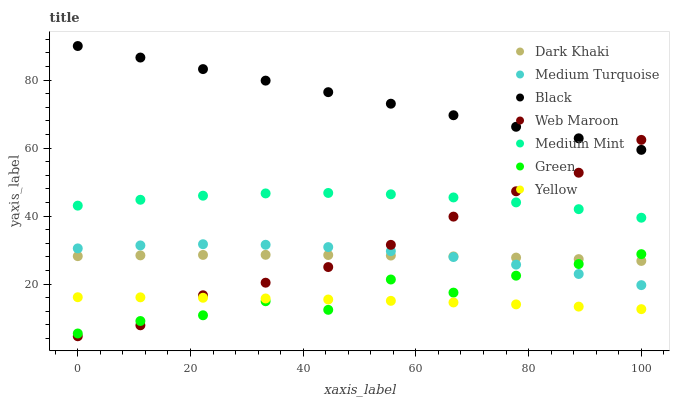Does Yellow have the minimum area under the curve?
Answer yes or no. Yes. Does Black have the maximum area under the curve?
Answer yes or no. Yes. Does Web Maroon have the minimum area under the curve?
Answer yes or no. No. Does Web Maroon have the maximum area under the curve?
Answer yes or no. No. Is Black the smoothest?
Answer yes or no. Yes. Is Green the roughest?
Answer yes or no. Yes. Is Web Maroon the smoothest?
Answer yes or no. No. Is Web Maroon the roughest?
Answer yes or no. No. Does Web Maroon have the lowest value?
Answer yes or no. Yes. Does Yellow have the lowest value?
Answer yes or no. No. Does Black have the highest value?
Answer yes or no. Yes. Does Web Maroon have the highest value?
Answer yes or no. No. Is Dark Khaki less than Black?
Answer yes or no. Yes. Is Medium Mint greater than Green?
Answer yes or no. Yes. Does Green intersect Web Maroon?
Answer yes or no. Yes. Is Green less than Web Maroon?
Answer yes or no. No. Is Green greater than Web Maroon?
Answer yes or no. No. Does Dark Khaki intersect Black?
Answer yes or no. No. 